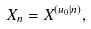<formula> <loc_0><loc_0><loc_500><loc_500>X _ { n } = X ^ { ( u _ { 0 } | n ) } ,</formula> 